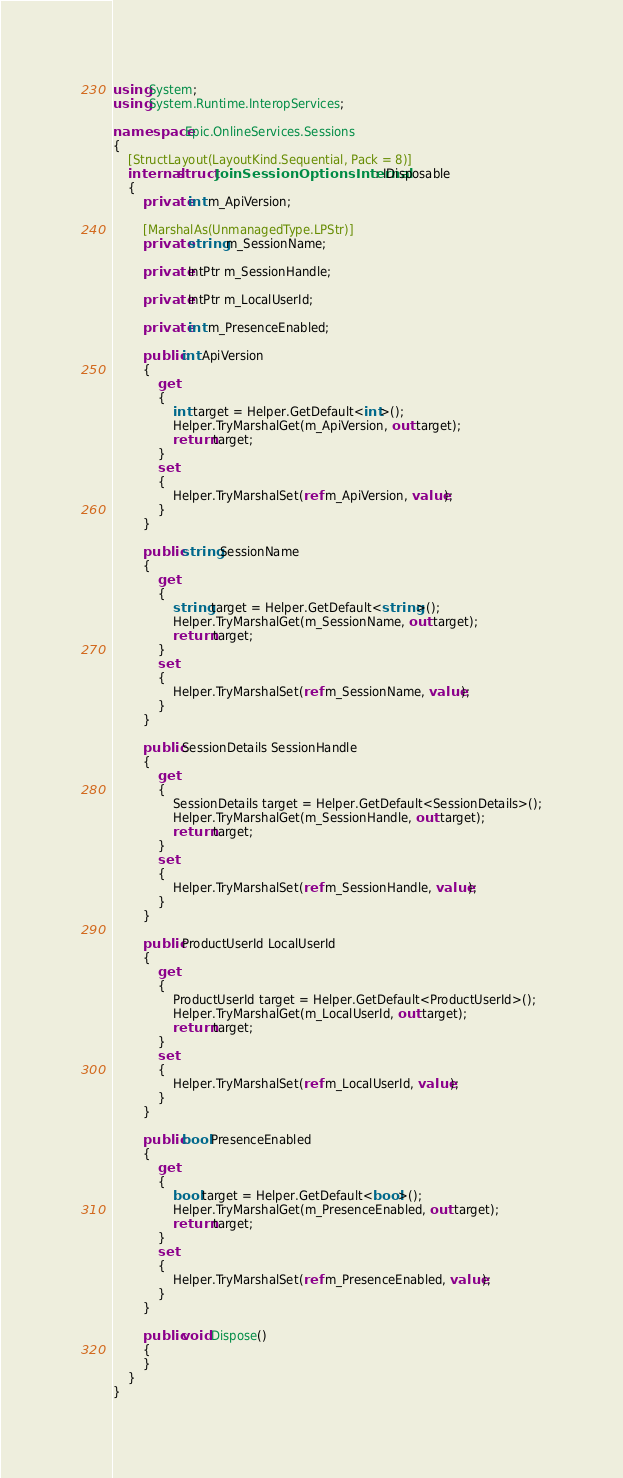Convert code to text. <code><loc_0><loc_0><loc_500><loc_500><_C#_>using System;
using System.Runtime.InteropServices;

namespace Epic.OnlineServices.Sessions
{
	[StructLayout(LayoutKind.Sequential, Pack = 8)]
	internal struct JoinSessionOptionsInternal : IDisposable
	{
		private int m_ApiVersion;

		[MarshalAs(UnmanagedType.LPStr)]
		private string m_SessionName;

		private IntPtr m_SessionHandle;

		private IntPtr m_LocalUserId;

		private int m_PresenceEnabled;

		public int ApiVersion
		{
			get
			{
				int target = Helper.GetDefault<int>();
				Helper.TryMarshalGet(m_ApiVersion, out target);
				return target;
			}
			set
			{
				Helper.TryMarshalSet(ref m_ApiVersion, value);
			}
		}

		public string SessionName
		{
			get
			{
				string target = Helper.GetDefault<string>();
				Helper.TryMarshalGet(m_SessionName, out target);
				return target;
			}
			set
			{
				Helper.TryMarshalSet(ref m_SessionName, value);
			}
		}

		public SessionDetails SessionHandle
		{
			get
			{
				SessionDetails target = Helper.GetDefault<SessionDetails>();
				Helper.TryMarshalGet(m_SessionHandle, out target);
				return target;
			}
			set
			{
				Helper.TryMarshalSet(ref m_SessionHandle, value);
			}
		}

		public ProductUserId LocalUserId
		{
			get
			{
				ProductUserId target = Helper.GetDefault<ProductUserId>();
				Helper.TryMarshalGet(m_LocalUserId, out target);
				return target;
			}
			set
			{
				Helper.TryMarshalSet(ref m_LocalUserId, value);
			}
		}

		public bool PresenceEnabled
		{
			get
			{
				bool target = Helper.GetDefault<bool>();
				Helper.TryMarshalGet(m_PresenceEnabled, out target);
				return target;
			}
			set
			{
				Helper.TryMarshalSet(ref m_PresenceEnabled, value);
			}
		}

		public void Dispose()
		{
		}
	}
}
</code> 